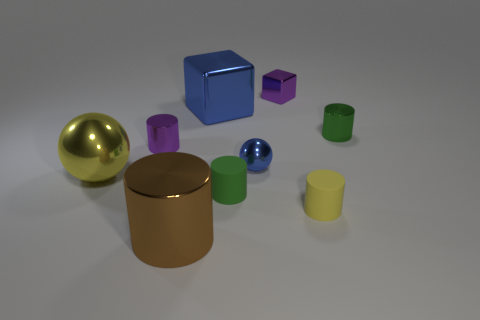How many green cylinders must be subtracted to get 1 green cylinders? 1 Subtract all purple cylinders. How many cylinders are left? 4 Subtract all purple cylinders. How many cylinders are left? 4 Add 1 blue cubes. How many objects exist? 10 Subtract all tiny rubber things. Subtract all tiny yellow rubber balls. How many objects are left? 7 Add 8 yellow objects. How many yellow objects are left? 10 Add 8 small purple things. How many small purple things exist? 10 Subtract 0 gray cylinders. How many objects are left? 9 Subtract all cubes. How many objects are left? 7 Subtract 1 spheres. How many spheres are left? 1 